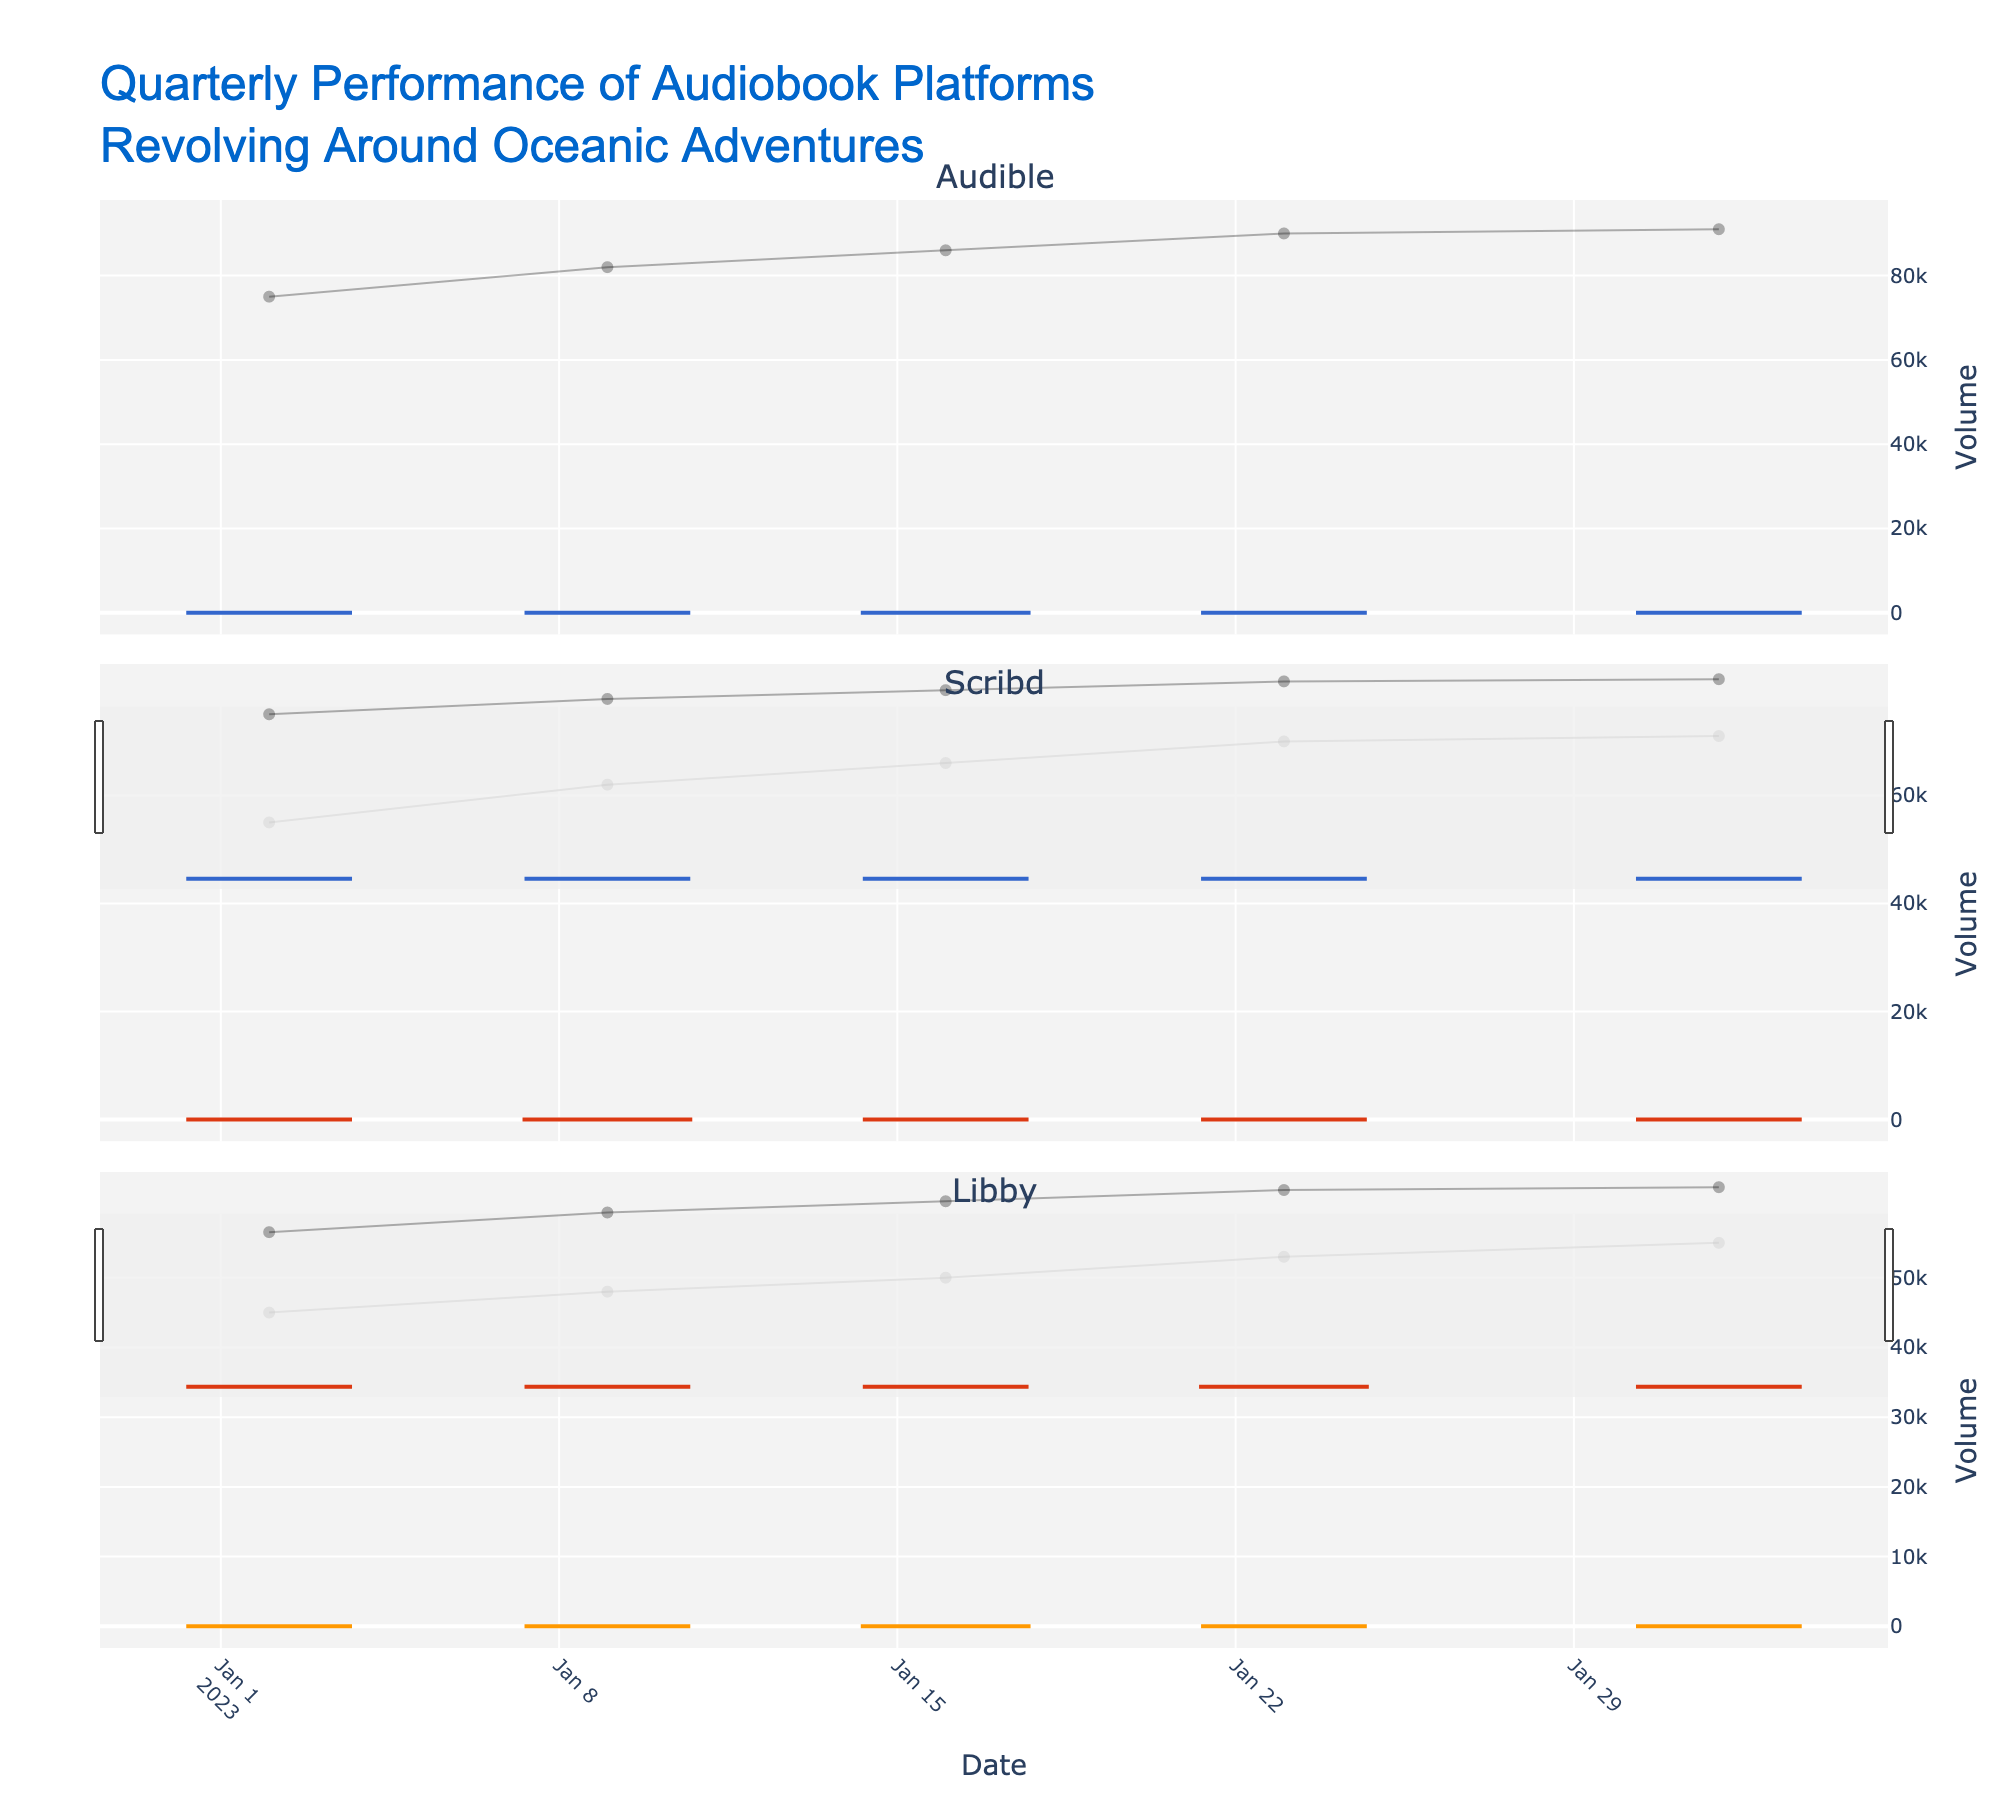What's the title of the figure? The title is usually located at the top of the figure, which is "Quarterly Performance of Audiobook Platforms Revolving Around Oceanic Adventures".
Answer: "Quarterly Performance of Audiobook Platforms Revolving Around Oceanic Adventures" Which platform has the highest closing price at the end of the time period? By looking at the candlestick plots of all three platforms, we can see the closing prices for the last date (2023-02-01) are 18.90 for Audible, 15.90 for Scribd, and 12.80 for Libby. Audible has the highest closing price.
Answer: Audible What is the color used for increasing prices in the Scribd plot? The color of the increasing line for Scribd is usually distinct and different from the other colors used. For Scribd, it is the second set of data and the color used is red.
Answer: Red Compare the opening price of Audible and Scribd on 2023-01-09. Which one is higher? Looking at the candlestick plots, the opening prices are 15.75 for Audible and 12.75 for Scribd. Audible's opening price is higher.
Answer: Audible How did the volume change for Libby from 2023-01-09 to 2023-01-16? The volume for Libby on 2023-01-09 is 48,000 and on 2023-01-16 is 50,000. The volume increased by 2,000 units.
Answer: Increased by 2,000 What is the highest price reached by any platform during the time period? By examining the high values for each candlestick across all three plots, the highest price is observed for Audible on 2023-02-01 at 19.50.
Answer: 19.50 Which platform exhibits the most significant increase in closing price throughout the entire period? To determine the most significant increase, we look at the difference between the first and the last closing prices for each platform. Audible increased from 15.75 to 18.90 (a change of 3.15), Scribd from 12.75 to 15.90 (a change of 3.15), and Libby from 10.50 to 12.80 (a change of 2.30). Both Audible and Scribd show an increase of 3.15.
Answer: Audible and Scribd How many weeks of data are displayed for each platform? By counting the data points (candlesticks) in each subplot, we can see that each platform has 5 data points, representing 5 weeks.
Answer: 5 weeks When did Libby experience the biggest weekly increase in closing price? By comparing the closing prices week by week for Libby: 
10.50 -> 10.90 (increase of 0.40)
10.90 -> 11.70 (increase of 0.80)
11.70 -> 12.30 (increase of 0.60)
12.30 -> 12.80 (increase of 0.50)
The biggest increase of 0.80 occurred between 2023-01-09 and 2023-01-16.
Answer: 2023-01-16 What is the average volume for Audible across the displayed weeks? Summing up the volume values for Audible (75,000 + 82,000 + 86,000 + 90,000 + 91,000) equals 424,000, dividing by the number of weeks (5) gives us an average of 84,800.
Answer: 84,800 